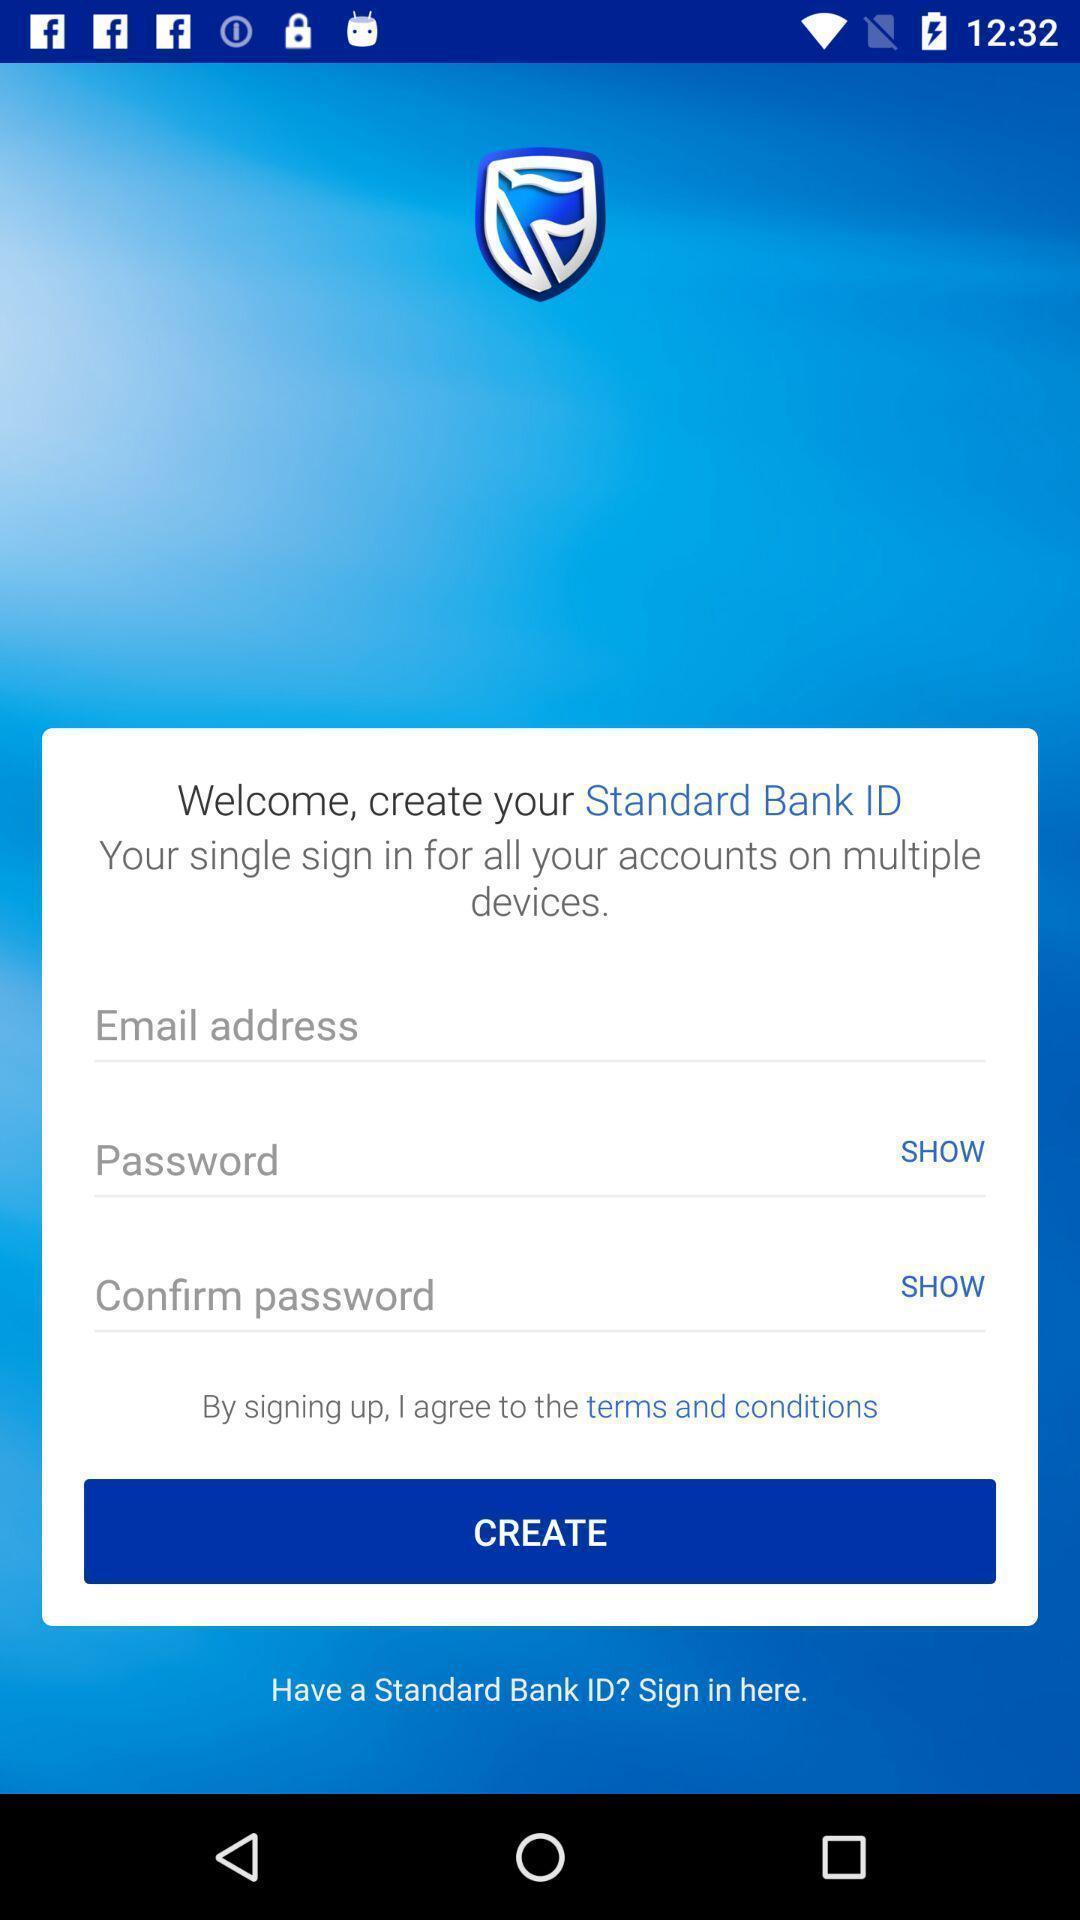Explain what's happening in this screen capture. Sign up page for the financial app. 